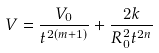<formula> <loc_0><loc_0><loc_500><loc_500>V = \frac { V _ { 0 } } { t ^ { 2 ( m + 1 ) } } + \frac { 2 k } { R _ { 0 } ^ { 2 } t ^ { 2 n } }</formula> 